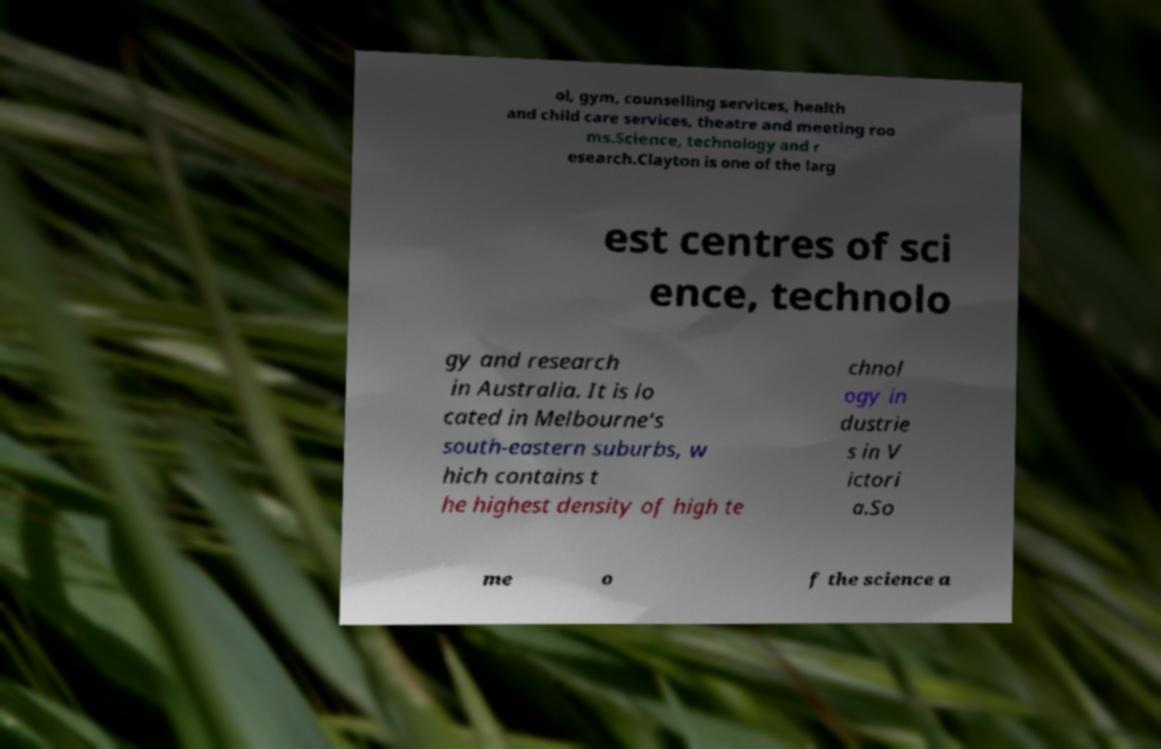Please identify and transcribe the text found in this image. ol, gym, counselling services, health and child care services, theatre and meeting roo ms.Science, technology and r esearch.Clayton is one of the larg est centres of sci ence, technolo gy and research in Australia. It is lo cated in Melbourne's south-eastern suburbs, w hich contains t he highest density of high te chnol ogy in dustrie s in V ictori a.So me o f the science a 